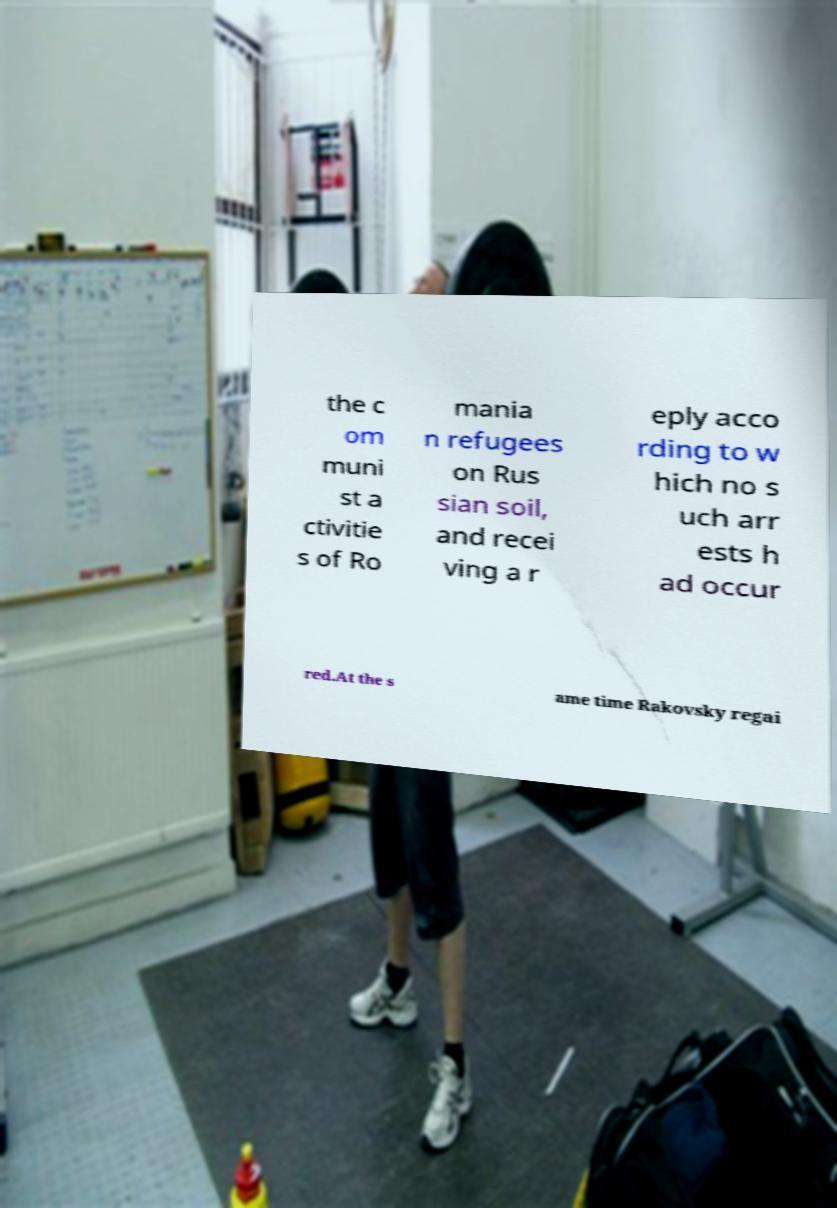Could you assist in decoding the text presented in this image and type it out clearly? the c om muni st a ctivitie s of Ro mania n refugees on Rus sian soil, and recei ving a r eply acco rding to w hich no s uch arr ests h ad occur red.At the s ame time Rakovsky regai 